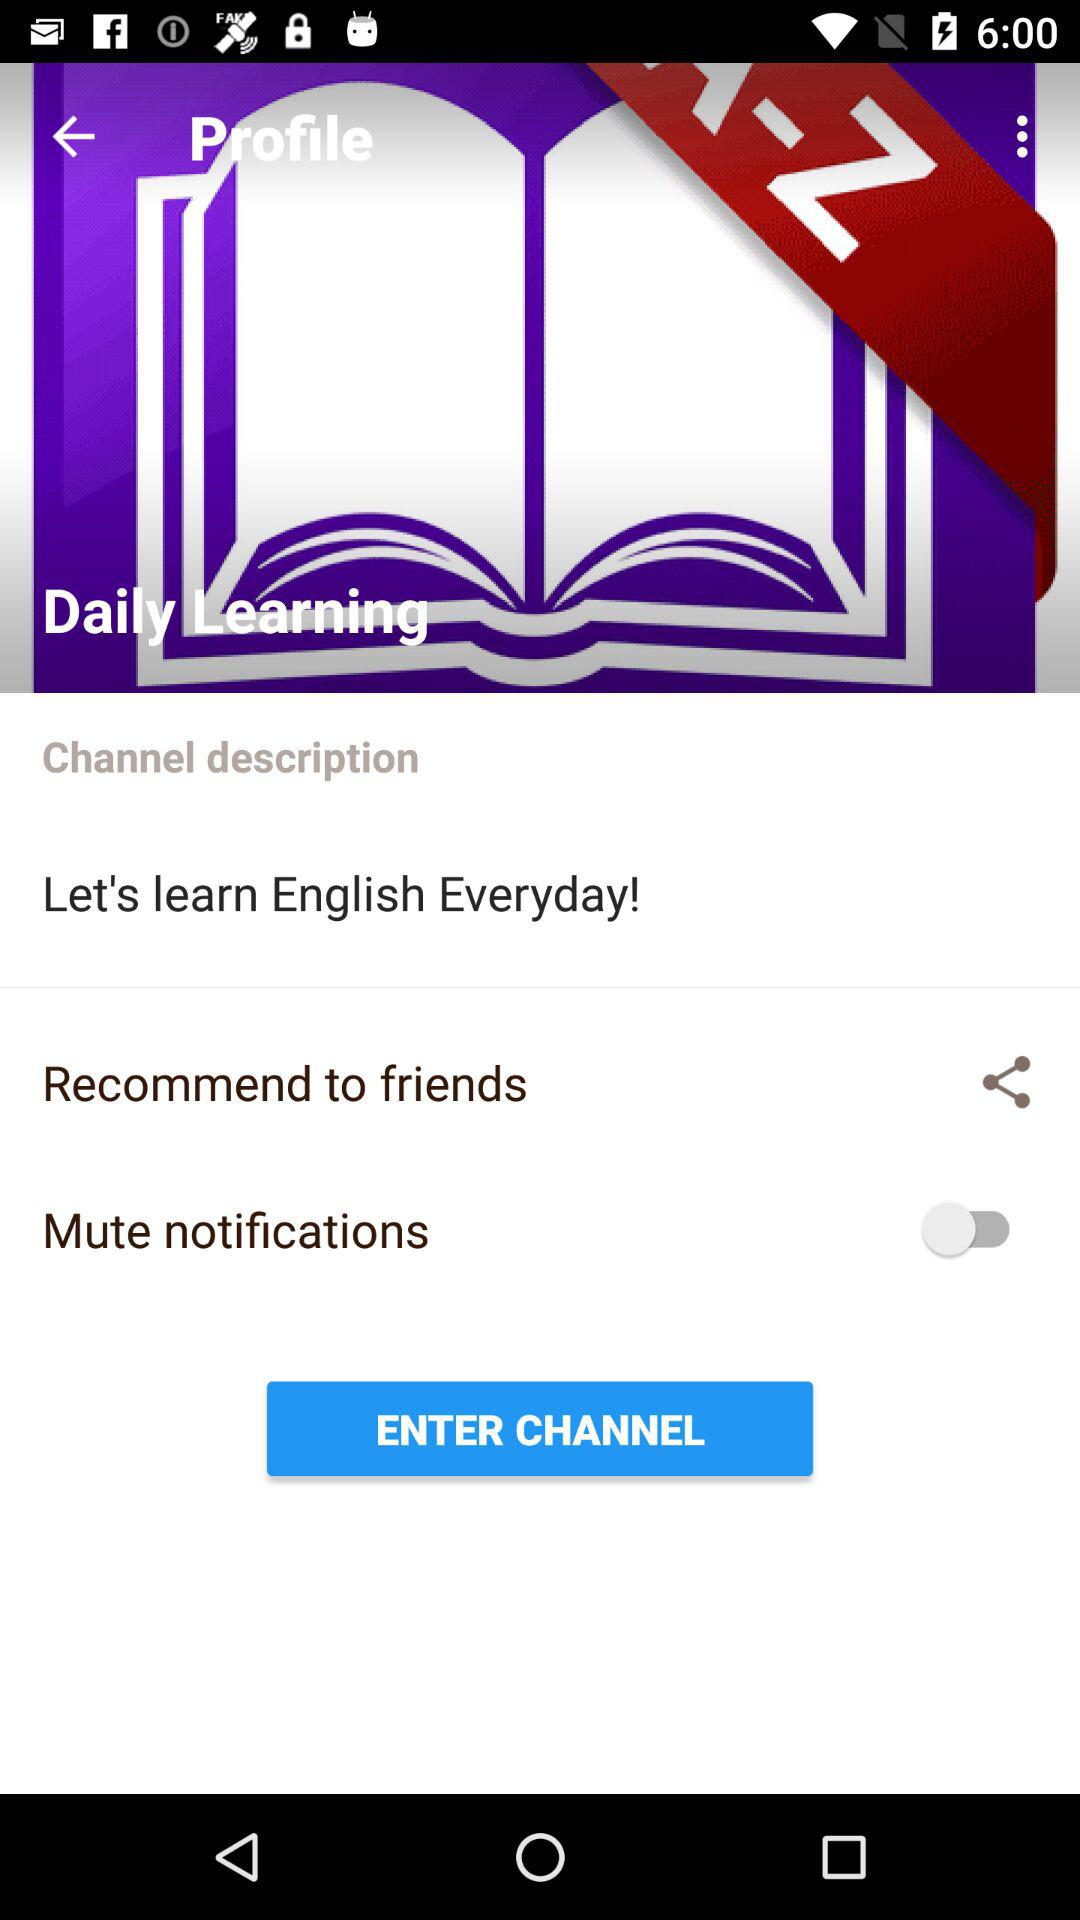What is the name of the channel? The channel name is "Daily Learning". 